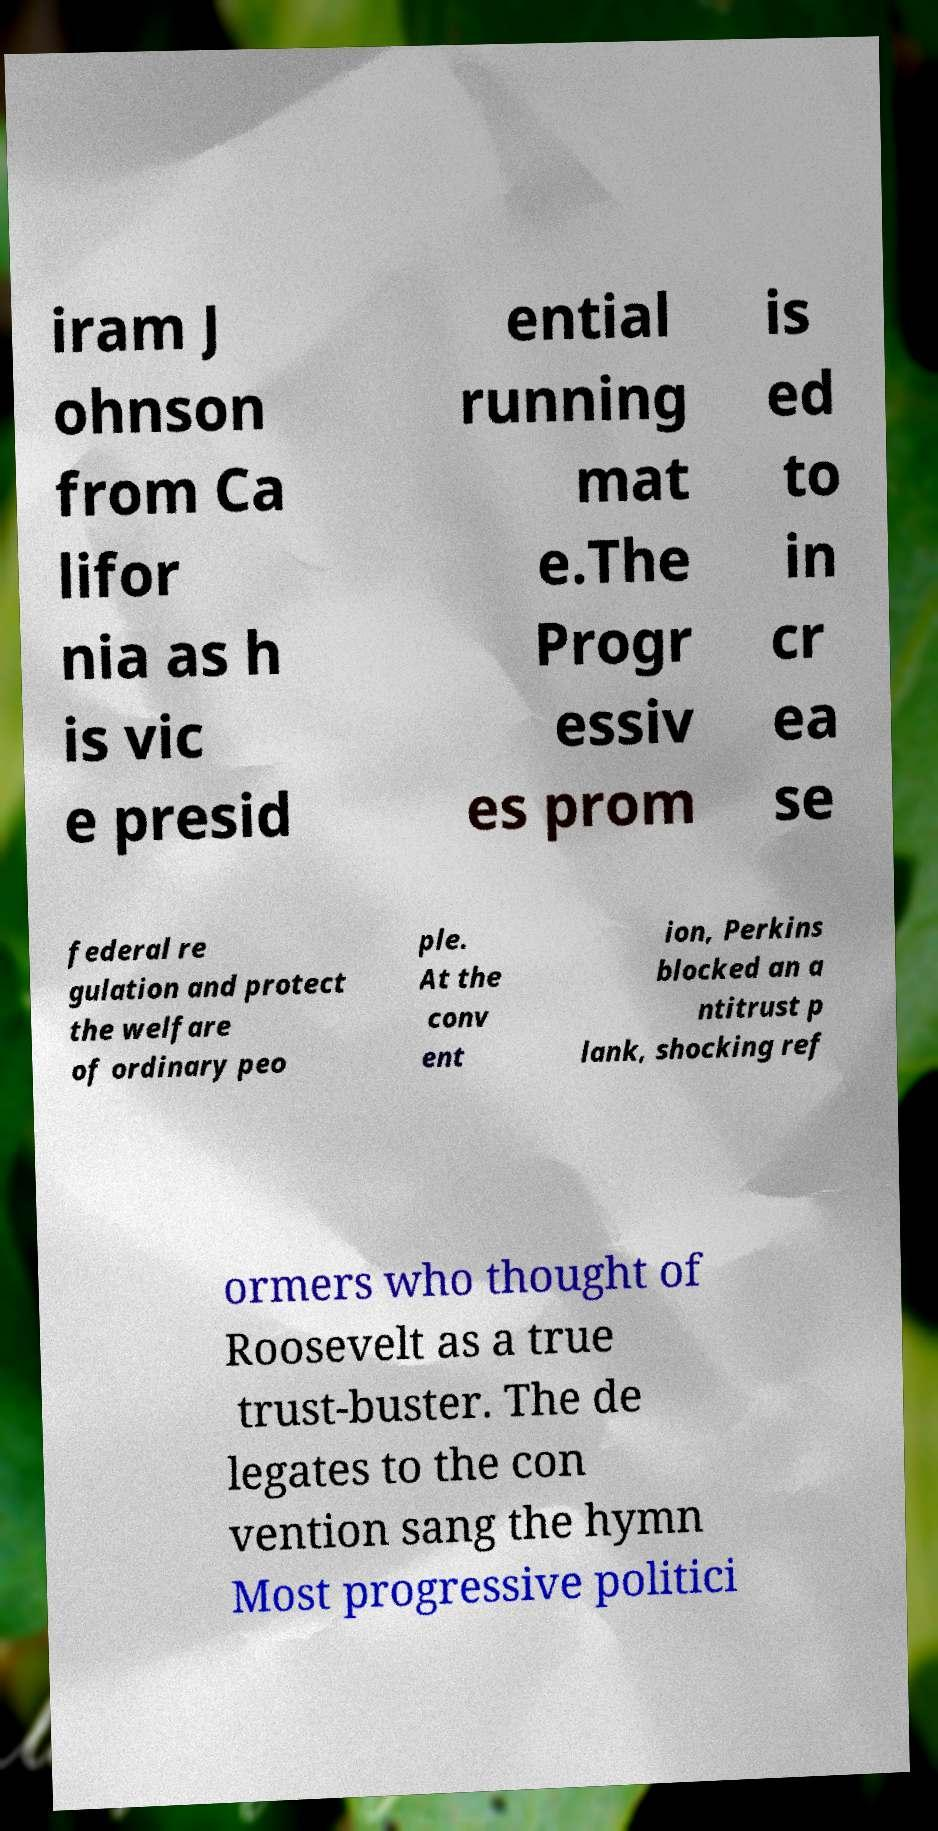Please identify and transcribe the text found in this image. iram J ohnson from Ca lifor nia as h is vic e presid ential running mat e.The Progr essiv es prom is ed to in cr ea se federal re gulation and protect the welfare of ordinary peo ple. At the conv ent ion, Perkins blocked an a ntitrust p lank, shocking ref ormers who thought of Roosevelt as a true trust-buster. The de legates to the con vention sang the hymn Most progressive politici 